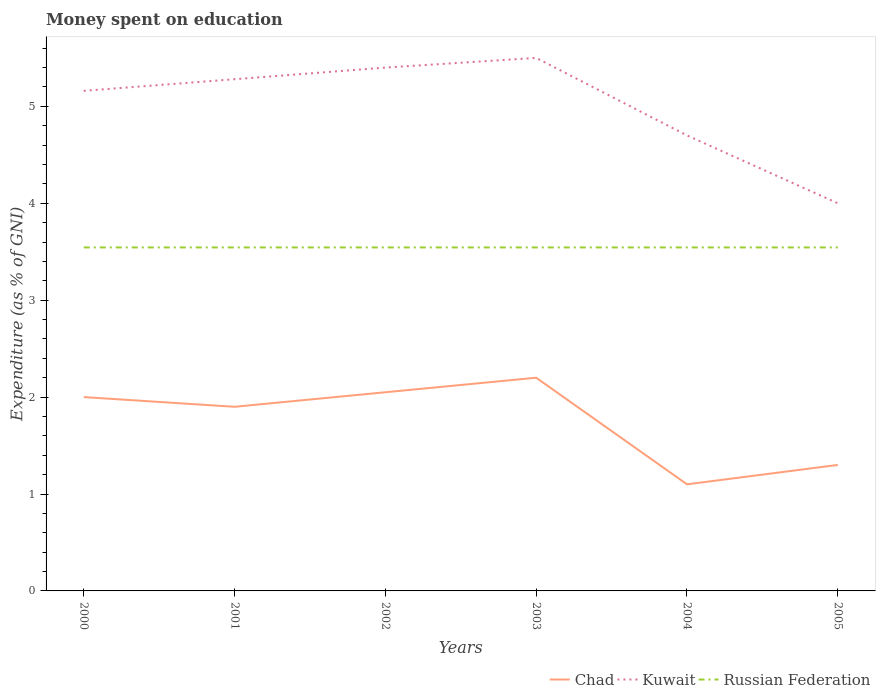Is the number of lines equal to the number of legend labels?
Provide a succinct answer. Yes. Across all years, what is the maximum amount of money spent on education in Russian Federation?
Offer a very short reply. 3.54. In which year was the amount of money spent on education in Chad maximum?
Give a very brief answer. 2004. What is the total amount of money spent on education in Kuwait in the graph?
Provide a succinct answer. -0.34. What is the difference between the highest and the second highest amount of money spent on education in Kuwait?
Your answer should be very brief. 1.5. Is the amount of money spent on education in Chad strictly greater than the amount of money spent on education in Kuwait over the years?
Ensure brevity in your answer.  Yes. What is the difference between two consecutive major ticks on the Y-axis?
Your answer should be compact. 1. Are the values on the major ticks of Y-axis written in scientific E-notation?
Offer a very short reply. No. Where does the legend appear in the graph?
Give a very brief answer. Bottom right. How are the legend labels stacked?
Your response must be concise. Horizontal. What is the title of the graph?
Provide a succinct answer. Money spent on education. What is the label or title of the X-axis?
Keep it short and to the point. Years. What is the label or title of the Y-axis?
Keep it short and to the point. Expenditure (as % of GNI). What is the Expenditure (as % of GNI) in Kuwait in 2000?
Offer a terse response. 5.16. What is the Expenditure (as % of GNI) of Russian Federation in 2000?
Make the answer very short. 3.54. What is the Expenditure (as % of GNI) of Chad in 2001?
Provide a succinct answer. 1.9. What is the Expenditure (as % of GNI) of Kuwait in 2001?
Provide a succinct answer. 5.28. What is the Expenditure (as % of GNI) in Russian Federation in 2001?
Provide a succinct answer. 3.54. What is the Expenditure (as % of GNI) of Chad in 2002?
Make the answer very short. 2.05. What is the Expenditure (as % of GNI) in Russian Federation in 2002?
Offer a very short reply. 3.54. What is the Expenditure (as % of GNI) of Chad in 2003?
Provide a succinct answer. 2.2. What is the Expenditure (as % of GNI) in Kuwait in 2003?
Your answer should be very brief. 5.5. What is the Expenditure (as % of GNI) in Russian Federation in 2003?
Provide a succinct answer. 3.54. What is the Expenditure (as % of GNI) of Chad in 2004?
Ensure brevity in your answer.  1.1. What is the Expenditure (as % of GNI) of Kuwait in 2004?
Offer a very short reply. 4.7. What is the Expenditure (as % of GNI) of Russian Federation in 2004?
Give a very brief answer. 3.54. What is the Expenditure (as % of GNI) in Chad in 2005?
Provide a short and direct response. 1.3. What is the Expenditure (as % of GNI) of Kuwait in 2005?
Your response must be concise. 4. What is the Expenditure (as % of GNI) of Russian Federation in 2005?
Offer a terse response. 3.54. Across all years, what is the maximum Expenditure (as % of GNI) in Russian Federation?
Keep it short and to the point. 3.54. Across all years, what is the minimum Expenditure (as % of GNI) of Russian Federation?
Provide a short and direct response. 3.54. What is the total Expenditure (as % of GNI) in Chad in the graph?
Provide a short and direct response. 10.55. What is the total Expenditure (as % of GNI) in Kuwait in the graph?
Offer a terse response. 30.04. What is the total Expenditure (as % of GNI) in Russian Federation in the graph?
Offer a very short reply. 21.27. What is the difference between the Expenditure (as % of GNI) in Kuwait in 2000 and that in 2001?
Your answer should be compact. -0.12. What is the difference between the Expenditure (as % of GNI) in Russian Federation in 2000 and that in 2001?
Keep it short and to the point. 0. What is the difference between the Expenditure (as % of GNI) in Kuwait in 2000 and that in 2002?
Your response must be concise. -0.24. What is the difference between the Expenditure (as % of GNI) of Kuwait in 2000 and that in 2003?
Keep it short and to the point. -0.34. What is the difference between the Expenditure (as % of GNI) in Chad in 2000 and that in 2004?
Offer a very short reply. 0.9. What is the difference between the Expenditure (as % of GNI) of Kuwait in 2000 and that in 2004?
Your answer should be very brief. 0.46. What is the difference between the Expenditure (as % of GNI) of Russian Federation in 2000 and that in 2004?
Your response must be concise. 0. What is the difference between the Expenditure (as % of GNI) of Chad in 2000 and that in 2005?
Provide a succinct answer. 0.7. What is the difference between the Expenditure (as % of GNI) of Kuwait in 2000 and that in 2005?
Make the answer very short. 1.16. What is the difference between the Expenditure (as % of GNI) in Kuwait in 2001 and that in 2002?
Offer a very short reply. -0.12. What is the difference between the Expenditure (as % of GNI) in Russian Federation in 2001 and that in 2002?
Your answer should be very brief. 0. What is the difference between the Expenditure (as % of GNI) in Chad in 2001 and that in 2003?
Make the answer very short. -0.3. What is the difference between the Expenditure (as % of GNI) of Kuwait in 2001 and that in 2003?
Your answer should be very brief. -0.22. What is the difference between the Expenditure (as % of GNI) in Russian Federation in 2001 and that in 2003?
Offer a terse response. 0. What is the difference between the Expenditure (as % of GNI) in Chad in 2001 and that in 2004?
Offer a very short reply. 0.8. What is the difference between the Expenditure (as % of GNI) in Kuwait in 2001 and that in 2004?
Your answer should be compact. 0.58. What is the difference between the Expenditure (as % of GNI) of Kuwait in 2001 and that in 2005?
Offer a very short reply. 1.28. What is the difference between the Expenditure (as % of GNI) in Russian Federation in 2001 and that in 2005?
Provide a succinct answer. 0. What is the difference between the Expenditure (as % of GNI) of Chad in 2002 and that in 2003?
Make the answer very short. -0.15. What is the difference between the Expenditure (as % of GNI) of Kuwait in 2002 and that in 2003?
Offer a terse response. -0.1. What is the difference between the Expenditure (as % of GNI) in Russian Federation in 2002 and that in 2003?
Your response must be concise. 0. What is the difference between the Expenditure (as % of GNI) of Chad in 2002 and that in 2004?
Provide a short and direct response. 0.95. What is the difference between the Expenditure (as % of GNI) in Russian Federation in 2002 and that in 2004?
Provide a succinct answer. 0. What is the difference between the Expenditure (as % of GNI) of Kuwait in 2002 and that in 2005?
Keep it short and to the point. 1.4. What is the difference between the Expenditure (as % of GNI) in Russian Federation in 2003 and that in 2005?
Provide a succinct answer. 0. What is the difference between the Expenditure (as % of GNI) of Russian Federation in 2004 and that in 2005?
Give a very brief answer. 0. What is the difference between the Expenditure (as % of GNI) of Chad in 2000 and the Expenditure (as % of GNI) of Kuwait in 2001?
Provide a succinct answer. -3.28. What is the difference between the Expenditure (as % of GNI) in Chad in 2000 and the Expenditure (as % of GNI) in Russian Federation in 2001?
Your response must be concise. -1.54. What is the difference between the Expenditure (as % of GNI) in Kuwait in 2000 and the Expenditure (as % of GNI) in Russian Federation in 2001?
Offer a terse response. 1.62. What is the difference between the Expenditure (as % of GNI) in Chad in 2000 and the Expenditure (as % of GNI) in Kuwait in 2002?
Offer a terse response. -3.4. What is the difference between the Expenditure (as % of GNI) of Chad in 2000 and the Expenditure (as % of GNI) of Russian Federation in 2002?
Your answer should be compact. -1.54. What is the difference between the Expenditure (as % of GNI) in Kuwait in 2000 and the Expenditure (as % of GNI) in Russian Federation in 2002?
Offer a terse response. 1.62. What is the difference between the Expenditure (as % of GNI) in Chad in 2000 and the Expenditure (as % of GNI) in Russian Federation in 2003?
Provide a succinct answer. -1.54. What is the difference between the Expenditure (as % of GNI) of Kuwait in 2000 and the Expenditure (as % of GNI) of Russian Federation in 2003?
Your answer should be very brief. 1.62. What is the difference between the Expenditure (as % of GNI) in Chad in 2000 and the Expenditure (as % of GNI) in Russian Federation in 2004?
Provide a succinct answer. -1.54. What is the difference between the Expenditure (as % of GNI) of Kuwait in 2000 and the Expenditure (as % of GNI) of Russian Federation in 2004?
Provide a succinct answer. 1.62. What is the difference between the Expenditure (as % of GNI) of Chad in 2000 and the Expenditure (as % of GNI) of Kuwait in 2005?
Offer a terse response. -2. What is the difference between the Expenditure (as % of GNI) in Chad in 2000 and the Expenditure (as % of GNI) in Russian Federation in 2005?
Make the answer very short. -1.54. What is the difference between the Expenditure (as % of GNI) of Kuwait in 2000 and the Expenditure (as % of GNI) of Russian Federation in 2005?
Keep it short and to the point. 1.62. What is the difference between the Expenditure (as % of GNI) in Chad in 2001 and the Expenditure (as % of GNI) in Kuwait in 2002?
Provide a succinct answer. -3.5. What is the difference between the Expenditure (as % of GNI) in Chad in 2001 and the Expenditure (as % of GNI) in Russian Federation in 2002?
Keep it short and to the point. -1.64. What is the difference between the Expenditure (as % of GNI) in Kuwait in 2001 and the Expenditure (as % of GNI) in Russian Federation in 2002?
Make the answer very short. 1.74. What is the difference between the Expenditure (as % of GNI) of Chad in 2001 and the Expenditure (as % of GNI) of Russian Federation in 2003?
Give a very brief answer. -1.64. What is the difference between the Expenditure (as % of GNI) in Kuwait in 2001 and the Expenditure (as % of GNI) in Russian Federation in 2003?
Your answer should be very brief. 1.74. What is the difference between the Expenditure (as % of GNI) in Chad in 2001 and the Expenditure (as % of GNI) in Russian Federation in 2004?
Give a very brief answer. -1.64. What is the difference between the Expenditure (as % of GNI) in Kuwait in 2001 and the Expenditure (as % of GNI) in Russian Federation in 2004?
Your response must be concise. 1.74. What is the difference between the Expenditure (as % of GNI) in Chad in 2001 and the Expenditure (as % of GNI) in Russian Federation in 2005?
Your answer should be very brief. -1.64. What is the difference between the Expenditure (as % of GNI) in Kuwait in 2001 and the Expenditure (as % of GNI) in Russian Federation in 2005?
Keep it short and to the point. 1.74. What is the difference between the Expenditure (as % of GNI) in Chad in 2002 and the Expenditure (as % of GNI) in Kuwait in 2003?
Give a very brief answer. -3.45. What is the difference between the Expenditure (as % of GNI) of Chad in 2002 and the Expenditure (as % of GNI) of Russian Federation in 2003?
Provide a short and direct response. -1.49. What is the difference between the Expenditure (as % of GNI) in Kuwait in 2002 and the Expenditure (as % of GNI) in Russian Federation in 2003?
Offer a very short reply. 1.86. What is the difference between the Expenditure (as % of GNI) of Chad in 2002 and the Expenditure (as % of GNI) of Kuwait in 2004?
Offer a very short reply. -2.65. What is the difference between the Expenditure (as % of GNI) in Chad in 2002 and the Expenditure (as % of GNI) in Russian Federation in 2004?
Your answer should be very brief. -1.49. What is the difference between the Expenditure (as % of GNI) in Kuwait in 2002 and the Expenditure (as % of GNI) in Russian Federation in 2004?
Your response must be concise. 1.86. What is the difference between the Expenditure (as % of GNI) of Chad in 2002 and the Expenditure (as % of GNI) of Kuwait in 2005?
Give a very brief answer. -1.95. What is the difference between the Expenditure (as % of GNI) in Chad in 2002 and the Expenditure (as % of GNI) in Russian Federation in 2005?
Provide a short and direct response. -1.49. What is the difference between the Expenditure (as % of GNI) of Kuwait in 2002 and the Expenditure (as % of GNI) of Russian Federation in 2005?
Your response must be concise. 1.86. What is the difference between the Expenditure (as % of GNI) in Chad in 2003 and the Expenditure (as % of GNI) in Russian Federation in 2004?
Provide a succinct answer. -1.34. What is the difference between the Expenditure (as % of GNI) in Kuwait in 2003 and the Expenditure (as % of GNI) in Russian Federation in 2004?
Provide a short and direct response. 1.96. What is the difference between the Expenditure (as % of GNI) in Chad in 2003 and the Expenditure (as % of GNI) in Russian Federation in 2005?
Ensure brevity in your answer.  -1.34. What is the difference between the Expenditure (as % of GNI) in Kuwait in 2003 and the Expenditure (as % of GNI) in Russian Federation in 2005?
Give a very brief answer. 1.96. What is the difference between the Expenditure (as % of GNI) in Chad in 2004 and the Expenditure (as % of GNI) in Russian Federation in 2005?
Your answer should be compact. -2.44. What is the difference between the Expenditure (as % of GNI) of Kuwait in 2004 and the Expenditure (as % of GNI) of Russian Federation in 2005?
Offer a very short reply. 1.16. What is the average Expenditure (as % of GNI) in Chad per year?
Give a very brief answer. 1.76. What is the average Expenditure (as % of GNI) of Kuwait per year?
Offer a very short reply. 5.01. What is the average Expenditure (as % of GNI) of Russian Federation per year?
Offer a terse response. 3.54. In the year 2000, what is the difference between the Expenditure (as % of GNI) of Chad and Expenditure (as % of GNI) of Kuwait?
Keep it short and to the point. -3.16. In the year 2000, what is the difference between the Expenditure (as % of GNI) in Chad and Expenditure (as % of GNI) in Russian Federation?
Keep it short and to the point. -1.54. In the year 2000, what is the difference between the Expenditure (as % of GNI) in Kuwait and Expenditure (as % of GNI) in Russian Federation?
Give a very brief answer. 1.62. In the year 2001, what is the difference between the Expenditure (as % of GNI) in Chad and Expenditure (as % of GNI) in Kuwait?
Provide a short and direct response. -3.38. In the year 2001, what is the difference between the Expenditure (as % of GNI) in Chad and Expenditure (as % of GNI) in Russian Federation?
Provide a succinct answer. -1.64. In the year 2001, what is the difference between the Expenditure (as % of GNI) of Kuwait and Expenditure (as % of GNI) of Russian Federation?
Provide a short and direct response. 1.74. In the year 2002, what is the difference between the Expenditure (as % of GNI) of Chad and Expenditure (as % of GNI) of Kuwait?
Offer a terse response. -3.35. In the year 2002, what is the difference between the Expenditure (as % of GNI) in Chad and Expenditure (as % of GNI) in Russian Federation?
Keep it short and to the point. -1.49. In the year 2002, what is the difference between the Expenditure (as % of GNI) of Kuwait and Expenditure (as % of GNI) of Russian Federation?
Ensure brevity in your answer.  1.86. In the year 2003, what is the difference between the Expenditure (as % of GNI) in Chad and Expenditure (as % of GNI) in Russian Federation?
Give a very brief answer. -1.34. In the year 2003, what is the difference between the Expenditure (as % of GNI) of Kuwait and Expenditure (as % of GNI) of Russian Federation?
Your response must be concise. 1.96. In the year 2004, what is the difference between the Expenditure (as % of GNI) of Chad and Expenditure (as % of GNI) of Russian Federation?
Provide a succinct answer. -2.44. In the year 2004, what is the difference between the Expenditure (as % of GNI) in Kuwait and Expenditure (as % of GNI) in Russian Federation?
Provide a succinct answer. 1.16. In the year 2005, what is the difference between the Expenditure (as % of GNI) of Chad and Expenditure (as % of GNI) of Kuwait?
Make the answer very short. -2.7. In the year 2005, what is the difference between the Expenditure (as % of GNI) in Chad and Expenditure (as % of GNI) in Russian Federation?
Make the answer very short. -2.24. In the year 2005, what is the difference between the Expenditure (as % of GNI) in Kuwait and Expenditure (as % of GNI) in Russian Federation?
Offer a very short reply. 0.46. What is the ratio of the Expenditure (as % of GNI) of Chad in 2000 to that in 2001?
Ensure brevity in your answer.  1.05. What is the ratio of the Expenditure (as % of GNI) in Kuwait in 2000 to that in 2001?
Offer a very short reply. 0.98. What is the ratio of the Expenditure (as % of GNI) in Russian Federation in 2000 to that in 2001?
Your answer should be very brief. 1. What is the ratio of the Expenditure (as % of GNI) of Chad in 2000 to that in 2002?
Your answer should be compact. 0.98. What is the ratio of the Expenditure (as % of GNI) of Kuwait in 2000 to that in 2002?
Provide a short and direct response. 0.96. What is the ratio of the Expenditure (as % of GNI) in Chad in 2000 to that in 2003?
Your answer should be compact. 0.91. What is the ratio of the Expenditure (as % of GNI) of Kuwait in 2000 to that in 2003?
Ensure brevity in your answer.  0.94. What is the ratio of the Expenditure (as % of GNI) of Chad in 2000 to that in 2004?
Keep it short and to the point. 1.82. What is the ratio of the Expenditure (as % of GNI) of Kuwait in 2000 to that in 2004?
Your response must be concise. 1.1. What is the ratio of the Expenditure (as % of GNI) in Russian Federation in 2000 to that in 2004?
Ensure brevity in your answer.  1. What is the ratio of the Expenditure (as % of GNI) of Chad in 2000 to that in 2005?
Offer a terse response. 1.54. What is the ratio of the Expenditure (as % of GNI) of Kuwait in 2000 to that in 2005?
Your response must be concise. 1.29. What is the ratio of the Expenditure (as % of GNI) of Russian Federation in 2000 to that in 2005?
Your response must be concise. 1. What is the ratio of the Expenditure (as % of GNI) of Chad in 2001 to that in 2002?
Offer a very short reply. 0.93. What is the ratio of the Expenditure (as % of GNI) of Kuwait in 2001 to that in 2002?
Offer a terse response. 0.98. What is the ratio of the Expenditure (as % of GNI) of Chad in 2001 to that in 2003?
Your answer should be compact. 0.86. What is the ratio of the Expenditure (as % of GNI) of Russian Federation in 2001 to that in 2003?
Give a very brief answer. 1. What is the ratio of the Expenditure (as % of GNI) of Chad in 2001 to that in 2004?
Offer a very short reply. 1.73. What is the ratio of the Expenditure (as % of GNI) of Kuwait in 2001 to that in 2004?
Ensure brevity in your answer.  1.12. What is the ratio of the Expenditure (as % of GNI) of Russian Federation in 2001 to that in 2004?
Make the answer very short. 1. What is the ratio of the Expenditure (as % of GNI) in Chad in 2001 to that in 2005?
Give a very brief answer. 1.46. What is the ratio of the Expenditure (as % of GNI) in Kuwait in 2001 to that in 2005?
Keep it short and to the point. 1.32. What is the ratio of the Expenditure (as % of GNI) in Russian Federation in 2001 to that in 2005?
Your answer should be compact. 1. What is the ratio of the Expenditure (as % of GNI) of Chad in 2002 to that in 2003?
Ensure brevity in your answer.  0.93. What is the ratio of the Expenditure (as % of GNI) of Kuwait in 2002 to that in 2003?
Provide a short and direct response. 0.98. What is the ratio of the Expenditure (as % of GNI) of Russian Federation in 2002 to that in 2003?
Keep it short and to the point. 1. What is the ratio of the Expenditure (as % of GNI) of Chad in 2002 to that in 2004?
Offer a very short reply. 1.86. What is the ratio of the Expenditure (as % of GNI) of Kuwait in 2002 to that in 2004?
Make the answer very short. 1.15. What is the ratio of the Expenditure (as % of GNI) in Russian Federation in 2002 to that in 2004?
Your answer should be compact. 1. What is the ratio of the Expenditure (as % of GNI) of Chad in 2002 to that in 2005?
Your answer should be very brief. 1.58. What is the ratio of the Expenditure (as % of GNI) in Kuwait in 2002 to that in 2005?
Provide a succinct answer. 1.35. What is the ratio of the Expenditure (as % of GNI) of Chad in 2003 to that in 2004?
Give a very brief answer. 2. What is the ratio of the Expenditure (as % of GNI) in Kuwait in 2003 to that in 2004?
Provide a short and direct response. 1.17. What is the ratio of the Expenditure (as % of GNI) of Chad in 2003 to that in 2005?
Provide a succinct answer. 1.69. What is the ratio of the Expenditure (as % of GNI) in Kuwait in 2003 to that in 2005?
Keep it short and to the point. 1.38. What is the ratio of the Expenditure (as % of GNI) in Russian Federation in 2003 to that in 2005?
Provide a short and direct response. 1. What is the ratio of the Expenditure (as % of GNI) of Chad in 2004 to that in 2005?
Offer a terse response. 0.85. What is the ratio of the Expenditure (as % of GNI) in Kuwait in 2004 to that in 2005?
Provide a short and direct response. 1.18. What is the ratio of the Expenditure (as % of GNI) in Russian Federation in 2004 to that in 2005?
Give a very brief answer. 1. What is the difference between the highest and the second highest Expenditure (as % of GNI) of Kuwait?
Ensure brevity in your answer.  0.1. What is the difference between the highest and the lowest Expenditure (as % of GNI) in Chad?
Give a very brief answer. 1.1. What is the difference between the highest and the lowest Expenditure (as % of GNI) of Kuwait?
Offer a very short reply. 1.5. 